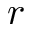Convert formula to latex. <formula><loc_0><loc_0><loc_500><loc_500>r</formula> 